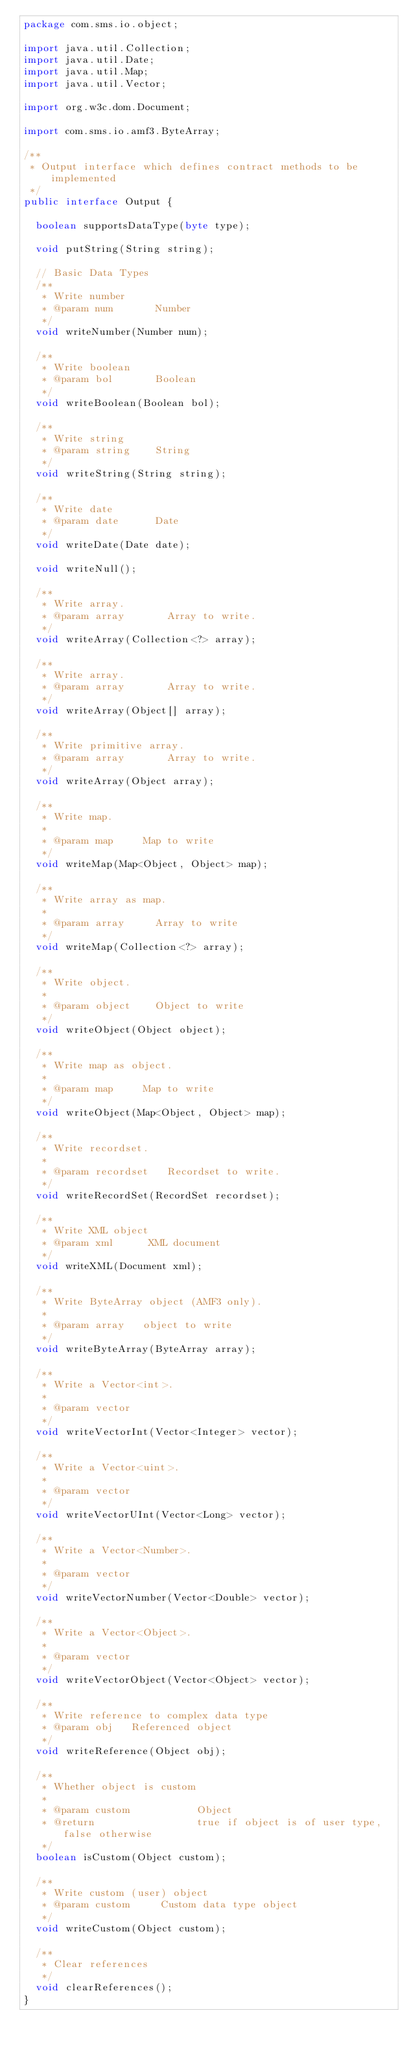Convert code to text. <code><loc_0><loc_0><loc_500><loc_500><_Java_>package com.sms.io.object;

import java.util.Collection;
import java.util.Date;
import java.util.Map;
import java.util.Vector;

import org.w3c.dom.Document;

import com.sms.io.amf3.ByteArray;

/**
 * Output interface which defines contract methods to be implemented
 */
public interface Output {

	boolean supportsDataType(byte type);

	void putString(String string);

	// Basic Data Types
	/**
	 * Write number
	 * @param num       Number
	 */
	void writeNumber(Number num);

	/**
	 * Write boolean
	 * @param bol       Boolean
	 */
	void writeBoolean(Boolean bol);

	/**
	 * Write string
	 * @param string    String
	 */
	void writeString(String string);

	/**
	 * Write date
	 * @param date      Date
	 */
	void writeDate(Date date);

	void writeNull();

	/**
	 * Write array.
	 * @param array     	Array to write.
	 */
	void writeArray(Collection<?> array);

	/**
	 * Write array.
	 * @param array     	Array to write.
	 */
	void writeArray(Object[] array);

	/**
	 * Write primitive array.
	 * @param array     	Array to write.
	 */
	void writeArray(Object array);

	/**
	 * Write map.
	 *
	 * @param map			Map to write
	 */
	void writeMap(Map<Object, Object> map);

	/**
	 * Write array as map.
	 *
	 * @param array			Array to write
	 */
	void writeMap(Collection<?> array);

	/**
	 * Write object.
	 *
	 * @param object		Object to write
	 */
	void writeObject(Object object);

	/**
	 * Write map as object.
	 *
	 * @param map			Map to write
	 */
	void writeObject(Map<Object, Object> map);

	/**
	 * Write recordset.
	 *
	 * @param recordset		Recordset to write.
	 */
	void writeRecordSet(RecordSet recordset);

	/**
	 * Write XML object
	 * @param xml      XML document
	 */
	void writeXML(Document xml);

	/**
	 * Write ByteArray object (AMF3 only).
	 * 
	 * @param array		object to write
	 */
	void writeByteArray(ByteArray array);

	/**
	 * Write a Vector<int>.
	 * 
	 * @param vector
	 */
	void writeVectorInt(Vector<Integer> vector);

	/**
	 * Write a Vector<uint>.
	 * 
	 * @param vector
	 */
	void writeVectorUInt(Vector<Long> vector);

	/**
	 * Write a Vector<Number>.
	 * 
	 * @param vector
	 */
	void writeVectorNumber(Vector<Double> vector);

	/**
	 * Write a Vector<Object>.
	 * 
	 * @param vector
	 */
	void writeVectorObject(Vector<Object> vector);

	/**
	 * Write reference to complex data type
	 * @param obj   Referenced object
	 */
	void writeReference(Object obj);

	/**
	 * Whether object is custom
	 *
	 * @param custom           Object
	 * @return                 true if object is of user type, false otherwise
	 */
	boolean isCustom(Object custom);

	/**
	 * Write custom (user) object
	 * @param custom     Custom data type object
	 */
	void writeCustom(Object custom);

	/**
	 * Clear references
	 */
	void clearReferences();
}
</code> 